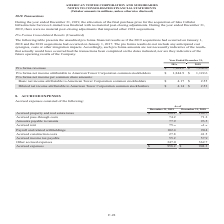According to American Tower Corporation's financial document, What was the Accrued property and real estate taxes in 2018? According to the financial document, $169.7 (in millions). The relevant text states: "Accrued property and real estate taxes $ 198.1 $ 169.7..." Also, What was the Accrued pass-through costs in 2018? According to the financial document, 71.2 (in millions). The relevant text states: "Accrued pass-through costs 74.2 71.2..." Also, What were the Accrued expenses in 2019? According to the financial document, $958.2 (in millions). The relevant text states: "Accrued expenses $ 958.2 $ 948.3..." Also, can you calculate: What was the change in Other accrued expenses between 2018 and 2019? Based on the calculation: 347.0-362.7, the result is -15.7 (in millions). This is based on the information: "Other accrued expenses 347.0 362.7 Other accrued expenses 347.0 362.7..." The key data points involved are: 347.0, 362.7. Also, can you calculate: What is the sum of the three highest expenses in 2019? Based on the calculation: 198.1+102.4+ 347.0 , the result is 647.5 (in millions). This is based on the information: "Accrued property and real estate taxes $ 198.1 $ 169.7 Other accrued expenses 347.0 362.7 Payroll and related withholdings 102.4 90.4..." The key data points involved are: 102.4, 198.1, 347.0. Also, can you calculate: What was the percentage change in accrued expenses between 2018 and 2019? To answer this question, I need to perform calculations using the financial data. The calculation is: ($958.2-$948.3)/$948.3, which equals 1.04 (percentage). This is based on the information: "Accrued expenses $ 958.2 $ 948.3 Accrued expenses $ 958.2 $ 948.3..." The key data points involved are: 948.3, 958.2. 